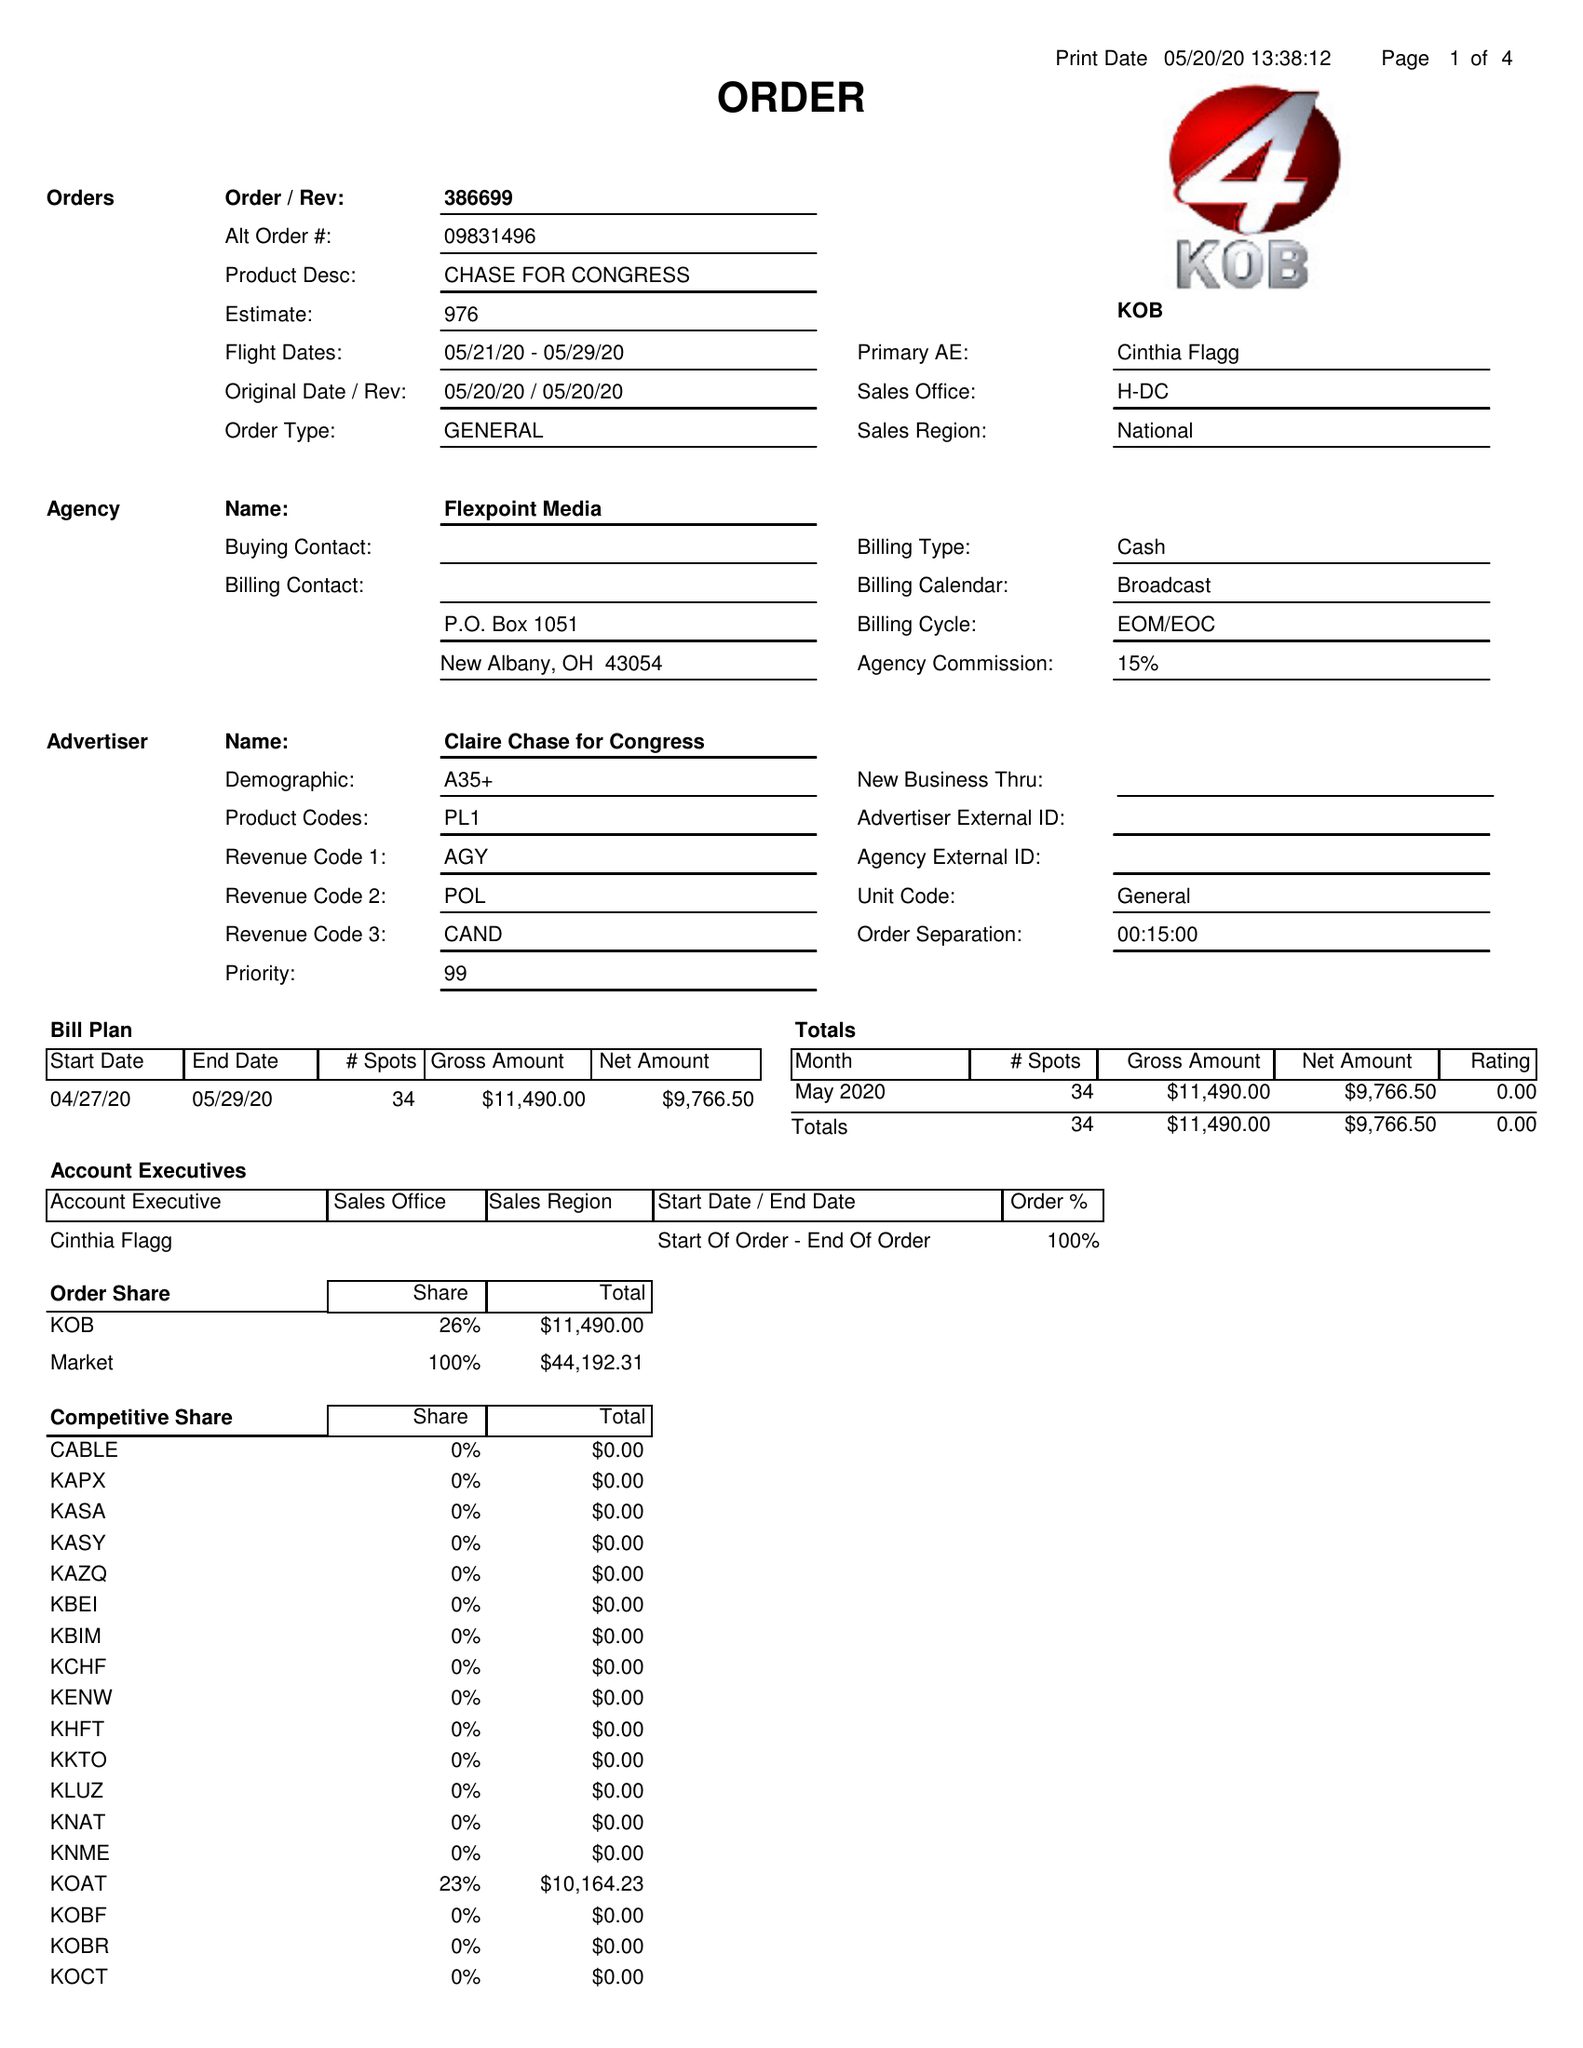What is the value for the contract_num?
Answer the question using a single word or phrase. 386699 